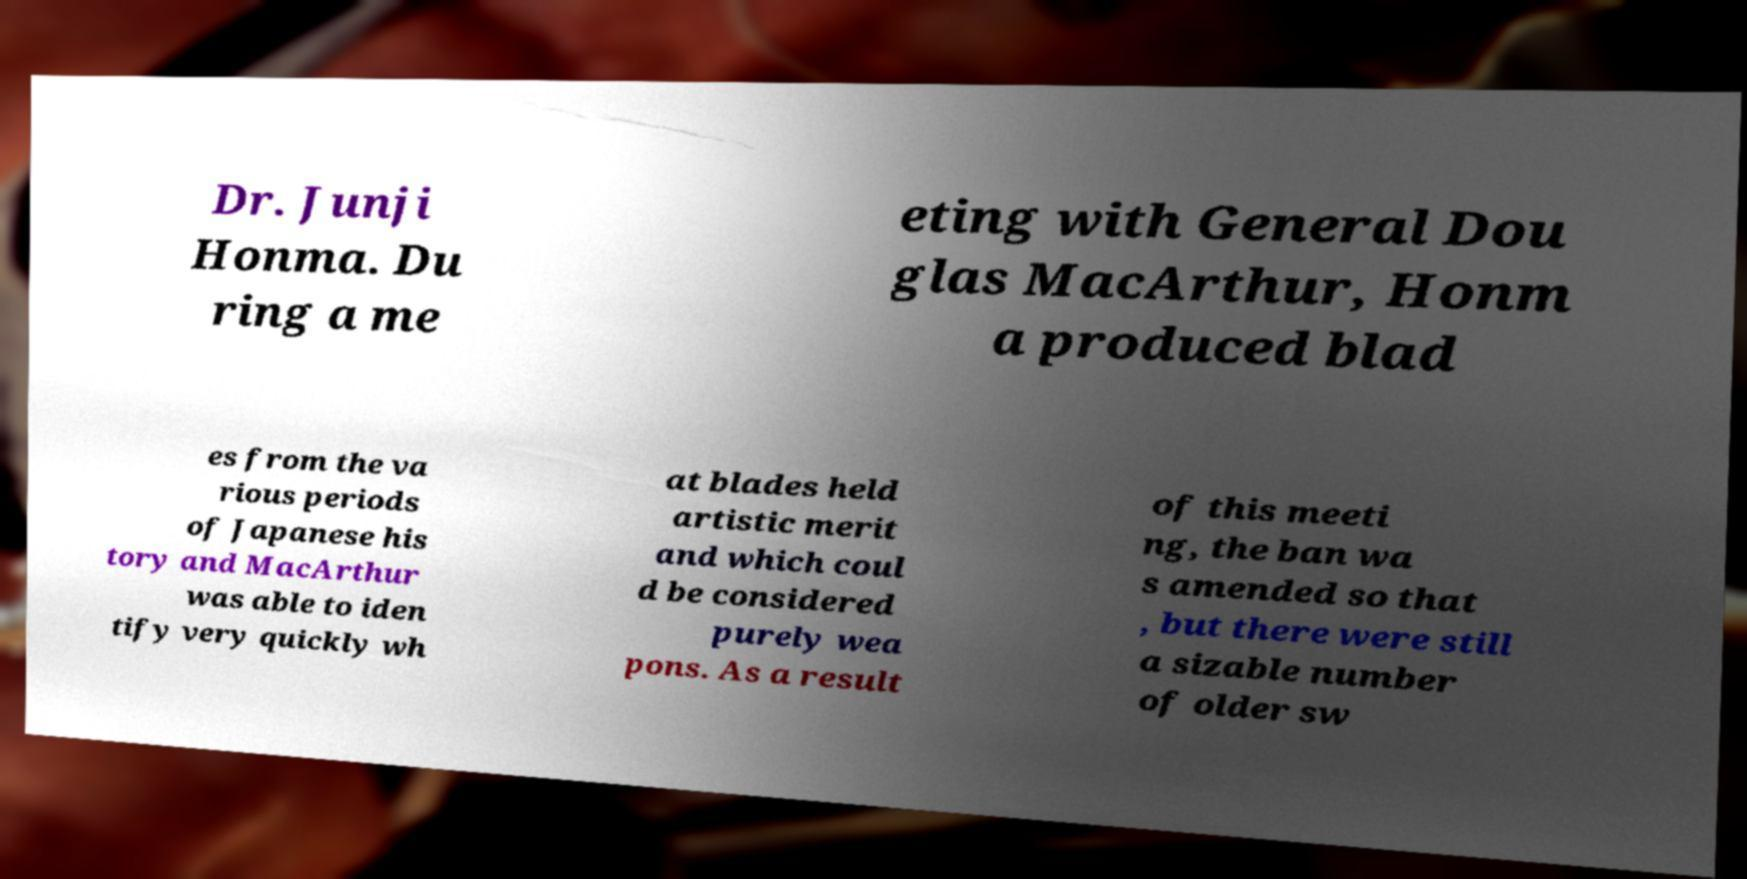Can you accurately transcribe the text from the provided image for me? Dr. Junji Honma. Du ring a me eting with General Dou glas MacArthur, Honm a produced blad es from the va rious periods of Japanese his tory and MacArthur was able to iden tify very quickly wh at blades held artistic merit and which coul d be considered purely wea pons. As a result of this meeti ng, the ban wa s amended so that , but there were still a sizable number of older sw 